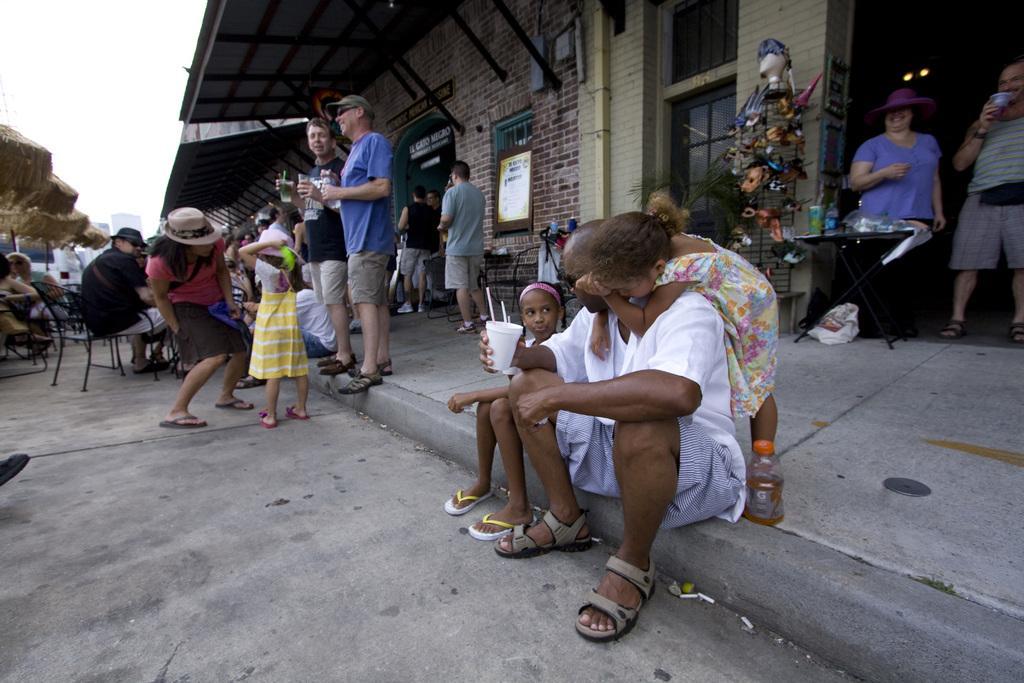In one or two sentences, can you explain what this image depicts? In this image there are so many people standing and sitting in front of a building where some of them are holding a coffee cup in hands. 